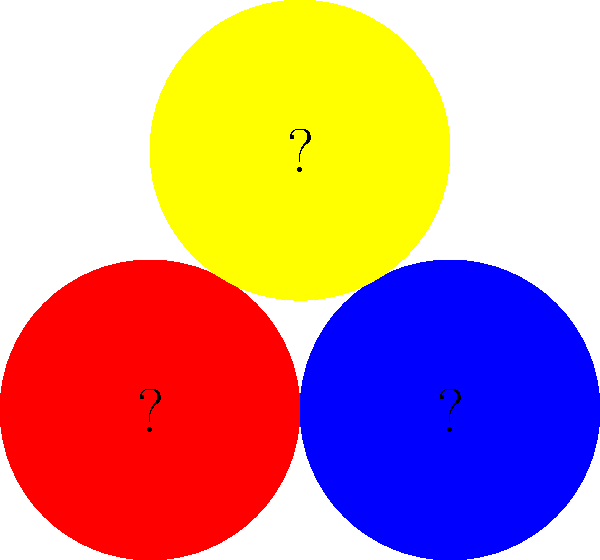What are the names of the three colors shown in the circles? 1. Look at the first circle on the left. This color is bright and warm. It is the color of fire trucks and strawberries. This color is called "red".

2. Look at the circle on the right. This color is cool and reminds us of the sky or ocean. It is the color of blueberries. This color is called "blue".

3. Look at the circle on top. This color is bright and sunny. It is the color of bananas and sunflowers. This color is called "yellow".

4. These three colors (red, blue, and yellow) are known as the primary colors. They are called primary because they cannot be made by mixing other colors together.

5. Remember: Red, Blue, Yellow are the names of these three basic colors.
Answer: Red, Blue, Yellow 